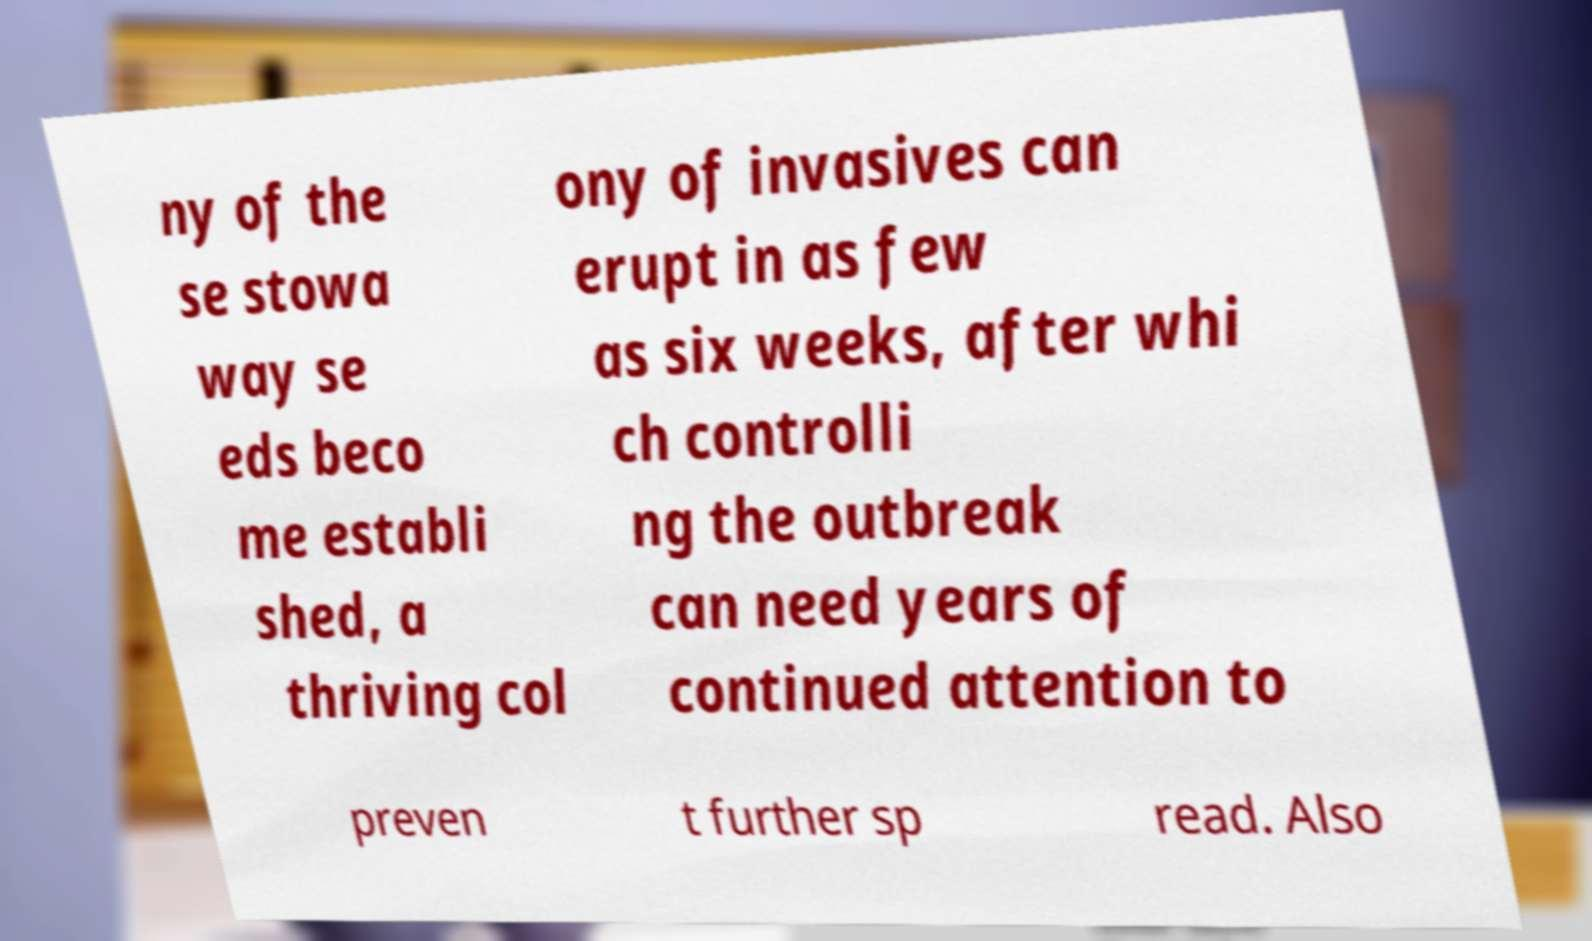Can you accurately transcribe the text from the provided image for me? ny of the se stowa way se eds beco me establi shed, a thriving col ony of invasives can erupt in as few as six weeks, after whi ch controlli ng the outbreak can need years of continued attention to preven t further sp read. Also 